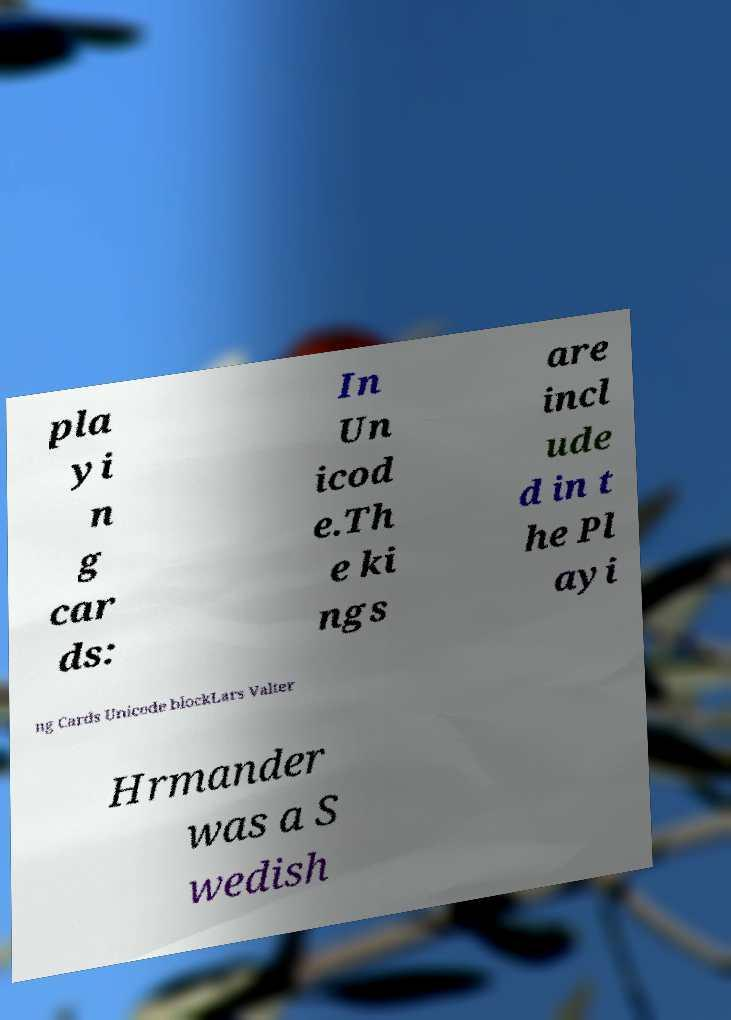What messages or text are displayed in this image? I need them in a readable, typed format. pla yi n g car ds: In Un icod e.Th e ki ngs are incl ude d in t he Pl ayi ng Cards Unicode blockLars Valter Hrmander was a S wedish 